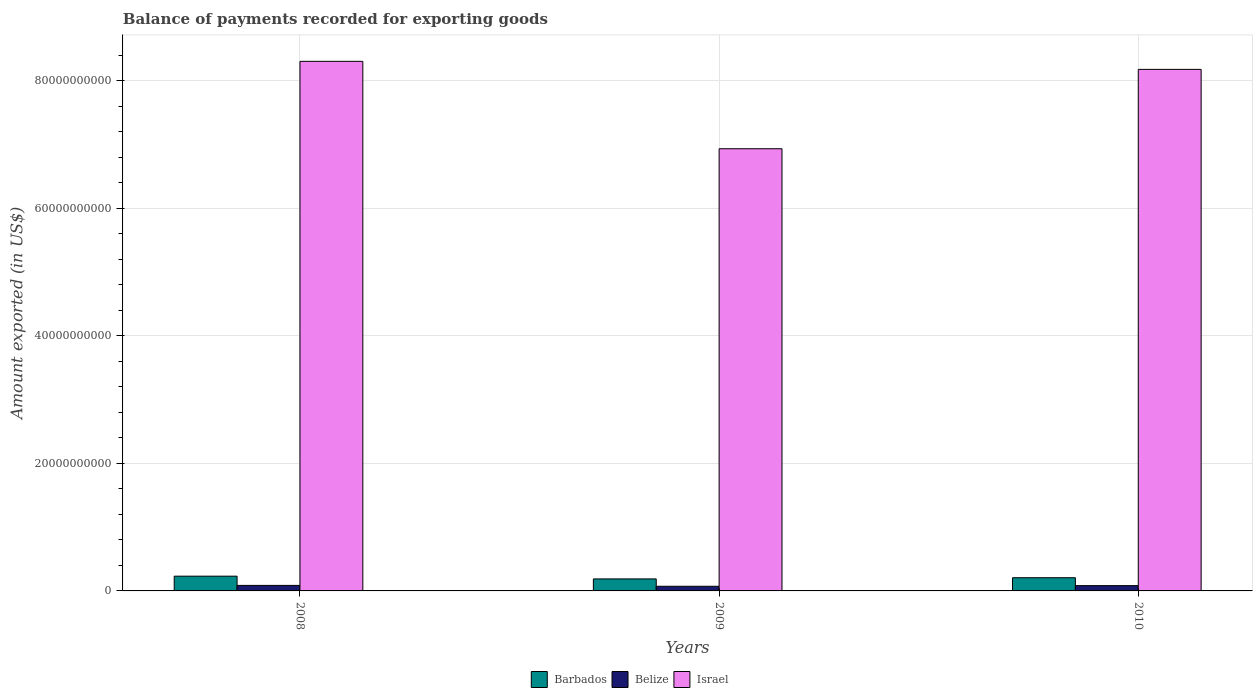How many different coloured bars are there?
Offer a terse response. 3. How many groups of bars are there?
Offer a very short reply. 3. What is the label of the 3rd group of bars from the left?
Keep it short and to the point. 2010. What is the amount exported in Barbados in 2010?
Your response must be concise. 2.07e+09. Across all years, what is the maximum amount exported in Barbados?
Provide a succinct answer. 2.31e+09. Across all years, what is the minimum amount exported in Belize?
Provide a short and direct response. 7.28e+08. In which year was the amount exported in Belize minimum?
Your answer should be compact. 2009. What is the total amount exported in Barbados in the graph?
Keep it short and to the point. 6.26e+09. What is the difference between the amount exported in Belize in 2008 and that in 2009?
Your answer should be compact. 1.38e+08. What is the difference between the amount exported in Barbados in 2010 and the amount exported in Israel in 2009?
Offer a terse response. -6.73e+1. What is the average amount exported in Barbados per year?
Your answer should be compact. 2.09e+09. In the year 2010, what is the difference between the amount exported in Belize and amount exported in Israel?
Your response must be concise. -8.10e+1. What is the ratio of the amount exported in Barbados in 2008 to that in 2010?
Make the answer very short. 1.12. Is the difference between the amount exported in Belize in 2008 and 2009 greater than the difference between the amount exported in Israel in 2008 and 2009?
Your answer should be very brief. No. What is the difference between the highest and the second highest amount exported in Israel?
Your response must be concise. 1.26e+09. What is the difference between the highest and the lowest amount exported in Barbados?
Ensure brevity in your answer.  4.28e+08. In how many years, is the amount exported in Israel greater than the average amount exported in Israel taken over all years?
Your response must be concise. 2. Is the sum of the amount exported in Barbados in 2008 and 2010 greater than the maximum amount exported in Israel across all years?
Provide a succinct answer. No. What does the 2nd bar from the left in 2010 represents?
Offer a very short reply. Belize. Are all the bars in the graph horizontal?
Keep it short and to the point. No. How many years are there in the graph?
Offer a very short reply. 3. What is the difference between two consecutive major ticks on the Y-axis?
Provide a succinct answer. 2.00e+1. How many legend labels are there?
Make the answer very short. 3. What is the title of the graph?
Ensure brevity in your answer.  Balance of payments recorded for exporting goods. Does "Belarus" appear as one of the legend labels in the graph?
Make the answer very short. No. What is the label or title of the Y-axis?
Your answer should be compact. Amount exported (in US$). What is the Amount exported (in US$) of Barbados in 2008?
Keep it short and to the point. 2.31e+09. What is the Amount exported (in US$) in Belize in 2008?
Offer a very short reply. 8.67e+08. What is the Amount exported (in US$) in Israel in 2008?
Your answer should be very brief. 8.30e+1. What is the Amount exported (in US$) of Barbados in 2009?
Provide a short and direct response. 1.88e+09. What is the Amount exported (in US$) in Belize in 2009?
Keep it short and to the point. 7.28e+08. What is the Amount exported (in US$) of Israel in 2009?
Provide a succinct answer. 6.93e+1. What is the Amount exported (in US$) of Barbados in 2010?
Ensure brevity in your answer.  2.07e+09. What is the Amount exported (in US$) in Belize in 2010?
Offer a very short reply. 8.30e+08. What is the Amount exported (in US$) of Israel in 2010?
Provide a succinct answer. 8.18e+1. Across all years, what is the maximum Amount exported (in US$) of Barbados?
Your answer should be compact. 2.31e+09. Across all years, what is the maximum Amount exported (in US$) of Belize?
Provide a succinct answer. 8.67e+08. Across all years, what is the maximum Amount exported (in US$) of Israel?
Your answer should be very brief. 8.30e+1. Across all years, what is the minimum Amount exported (in US$) of Barbados?
Offer a terse response. 1.88e+09. Across all years, what is the minimum Amount exported (in US$) of Belize?
Offer a very short reply. 7.28e+08. Across all years, what is the minimum Amount exported (in US$) in Israel?
Ensure brevity in your answer.  6.93e+1. What is the total Amount exported (in US$) in Barbados in the graph?
Your response must be concise. 6.26e+09. What is the total Amount exported (in US$) in Belize in the graph?
Keep it short and to the point. 2.42e+09. What is the total Amount exported (in US$) of Israel in the graph?
Keep it short and to the point. 2.34e+11. What is the difference between the Amount exported (in US$) of Barbados in 2008 and that in 2009?
Offer a very short reply. 4.28e+08. What is the difference between the Amount exported (in US$) in Belize in 2008 and that in 2009?
Keep it short and to the point. 1.38e+08. What is the difference between the Amount exported (in US$) of Israel in 2008 and that in 2009?
Provide a succinct answer. 1.37e+1. What is the difference between the Amount exported (in US$) of Barbados in 2008 and that in 2010?
Your answer should be very brief. 2.43e+08. What is the difference between the Amount exported (in US$) of Belize in 2008 and that in 2010?
Provide a succinct answer. 3.70e+07. What is the difference between the Amount exported (in US$) in Israel in 2008 and that in 2010?
Keep it short and to the point. 1.26e+09. What is the difference between the Amount exported (in US$) of Barbados in 2009 and that in 2010?
Keep it short and to the point. -1.85e+08. What is the difference between the Amount exported (in US$) in Belize in 2009 and that in 2010?
Give a very brief answer. -1.01e+08. What is the difference between the Amount exported (in US$) in Israel in 2009 and that in 2010?
Ensure brevity in your answer.  -1.24e+1. What is the difference between the Amount exported (in US$) in Barbados in 2008 and the Amount exported (in US$) in Belize in 2009?
Provide a short and direct response. 1.58e+09. What is the difference between the Amount exported (in US$) of Barbados in 2008 and the Amount exported (in US$) of Israel in 2009?
Your answer should be very brief. -6.70e+1. What is the difference between the Amount exported (in US$) of Belize in 2008 and the Amount exported (in US$) of Israel in 2009?
Your answer should be very brief. -6.85e+1. What is the difference between the Amount exported (in US$) in Barbados in 2008 and the Amount exported (in US$) in Belize in 2010?
Provide a short and direct response. 1.48e+09. What is the difference between the Amount exported (in US$) in Barbados in 2008 and the Amount exported (in US$) in Israel in 2010?
Offer a terse response. -7.95e+1. What is the difference between the Amount exported (in US$) in Belize in 2008 and the Amount exported (in US$) in Israel in 2010?
Offer a terse response. -8.09e+1. What is the difference between the Amount exported (in US$) of Barbados in 2009 and the Amount exported (in US$) of Belize in 2010?
Your response must be concise. 1.05e+09. What is the difference between the Amount exported (in US$) of Barbados in 2009 and the Amount exported (in US$) of Israel in 2010?
Keep it short and to the point. -7.99e+1. What is the difference between the Amount exported (in US$) of Belize in 2009 and the Amount exported (in US$) of Israel in 2010?
Provide a succinct answer. -8.11e+1. What is the average Amount exported (in US$) in Barbados per year?
Give a very brief answer. 2.09e+09. What is the average Amount exported (in US$) in Belize per year?
Provide a succinct answer. 8.08e+08. What is the average Amount exported (in US$) in Israel per year?
Provide a succinct answer. 7.81e+1. In the year 2008, what is the difference between the Amount exported (in US$) of Barbados and Amount exported (in US$) of Belize?
Give a very brief answer. 1.45e+09. In the year 2008, what is the difference between the Amount exported (in US$) in Barbados and Amount exported (in US$) in Israel?
Your response must be concise. -8.07e+1. In the year 2008, what is the difference between the Amount exported (in US$) in Belize and Amount exported (in US$) in Israel?
Make the answer very short. -8.22e+1. In the year 2009, what is the difference between the Amount exported (in US$) in Barbados and Amount exported (in US$) in Belize?
Your answer should be compact. 1.16e+09. In the year 2009, what is the difference between the Amount exported (in US$) in Barbados and Amount exported (in US$) in Israel?
Keep it short and to the point. -6.75e+1. In the year 2009, what is the difference between the Amount exported (in US$) of Belize and Amount exported (in US$) of Israel?
Keep it short and to the point. -6.86e+1. In the year 2010, what is the difference between the Amount exported (in US$) in Barbados and Amount exported (in US$) in Belize?
Offer a terse response. 1.24e+09. In the year 2010, what is the difference between the Amount exported (in US$) in Barbados and Amount exported (in US$) in Israel?
Give a very brief answer. -7.97e+1. In the year 2010, what is the difference between the Amount exported (in US$) in Belize and Amount exported (in US$) in Israel?
Provide a short and direct response. -8.10e+1. What is the ratio of the Amount exported (in US$) of Barbados in 2008 to that in 2009?
Offer a terse response. 1.23. What is the ratio of the Amount exported (in US$) of Belize in 2008 to that in 2009?
Keep it short and to the point. 1.19. What is the ratio of the Amount exported (in US$) in Israel in 2008 to that in 2009?
Offer a terse response. 1.2. What is the ratio of the Amount exported (in US$) in Barbados in 2008 to that in 2010?
Offer a terse response. 1.12. What is the ratio of the Amount exported (in US$) in Belize in 2008 to that in 2010?
Offer a terse response. 1.04. What is the ratio of the Amount exported (in US$) in Israel in 2008 to that in 2010?
Offer a very short reply. 1.02. What is the ratio of the Amount exported (in US$) of Barbados in 2009 to that in 2010?
Provide a short and direct response. 0.91. What is the ratio of the Amount exported (in US$) of Belize in 2009 to that in 2010?
Provide a short and direct response. 0.88. What is the ratio of the Amount exported (in US$) of Israel in 2009 to that in 2010?
Offer a very short reply. 0.85. What is the difference between the highest and the second highest Amount exported (in US$) of Barbados?
Offer a very short reply. 2.43e+08. What is the difference between the highest and the second highest Amount exported (in US$) of Belize?
Offer a very short reply. 3.70e+07. What is the difference between the highest and the second highest Amount exported (in US$) of Israel?
Make the answer very short. 1.26e+09. What is the difference between the highest and the lowest Amount exported (in US$) in Barbados?
Offer a very short reply. 4.28e+08. What is the difference between the highest and the lowest Amount exported (in US$) of Belize?
Your answer should be compact. 1.38e+08. What is the difference between the highest and the lowest Amount exported (in US$) in Israel?
Your answer should be very brief. 1.37e+1. 